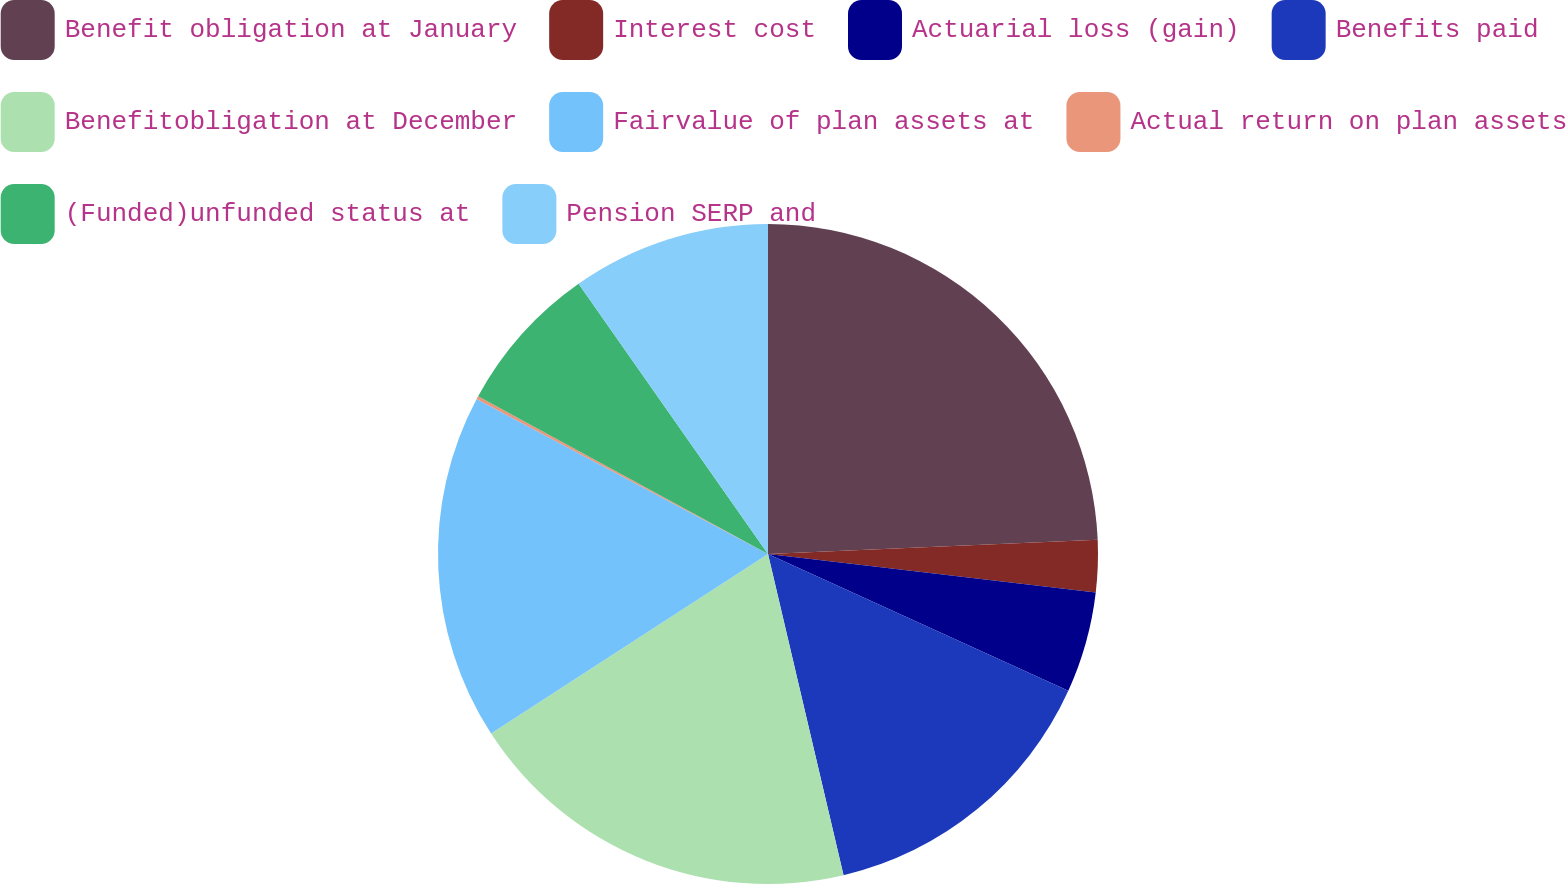Convert chart. <chart><loc_0><loc_0><loc_500><loc_500><pie_chart><fcel>Benefit obligation at January<fcel>Interest cost<fcel>Actuarial loss (gain)<fcel>Benefits paid<fcel>Benefitobligation at December<fcel>Fairvalue of plan assets at<fcel>Actual return on plan assets<fcel>(Funded)unfunded status at<fcel>Pension SERP and<nl><fcel>24.31%<fcel>2.55%<fcel>4.94%<fcel>14.52%<fcel>19.52%<fcel>16.93%<fcel>0.15%<fcel>7.34%<fcel>9.73%<nl></chart> 